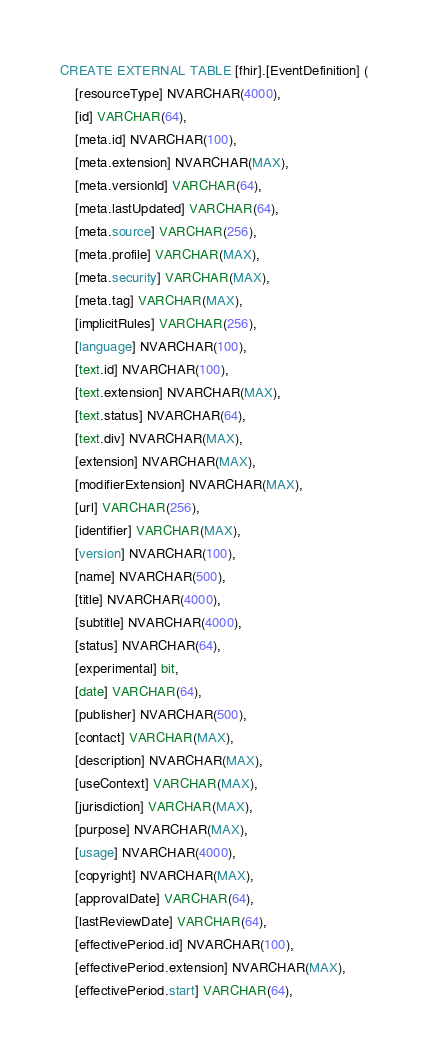<code> <loc_0><loc_0><loc_500><loc_500><_SQL_>CREATE EXTERNAL TABLE [fhir].[EventDefinition] (
    [resourceType] NVARCHAR(4000),
    [id] VARCHAR(64),
    [meta.id] NVARCHAR(100),
    [meta.extension] NVARCHAR(MAX),
    [meta.versionId] VARCHAR(64),
    [meta.lastUpdated] VARCHAR(64),
    [meta.source] VARCHAR(256),
    [meta.profile] VARCHAR(MAX),
    [meta.security] VARCHAR(MAX),
    [meta.tag] VARCHAR(MAX),
    [implicitRules] VARCHAR(256),
    [language] NVARCHAR(100),
    [text.id] NVARCHAR(100),
    [text.extension] NVARCHAR(MAX),
    [text.status] NVARCHAR(64),
    [text.div] NVARCHAR(MAX),
    [extension] NVARCHAR(MAX),
    [modifierExtension] NVARCHAR(MAX),
    [url] VARCHAR(256),
    [identifier] VARCHAR(MAX),
    [version] NVARCHAR(100),
    [name] NVARCHAR(500),
    [title] NVARCHAR(4000),
    [subtitle] NVARCHAR(4000),
    [status] NVARCHAR(64),
    [experimental] bit,
    [date] VARCHAR(64),
    [publisher] NVARCHAR(500),
    [contact] VARCHAR(MAX),
    [description] NVARCHAR(MAX),
    [useContext] VARCHAR(MAX),
    [jurisdiction] VARCHAR(MAX),
    [purpose] NVARCHAR(MAX),
    [usage] NVARCHAR(4000),
    [copyright] NVARCHAR(MAX),
    [approvalDate] VARCHAR(64),
    [lastReviewDate] VARCHAR(64),
    [effectivePeriod.id] NVARCHAR(100),
    [effectivePeriod.extension] NVARCHAR(MAX),
    [effectivePeriod.start] VARCHAR(64),</code> 